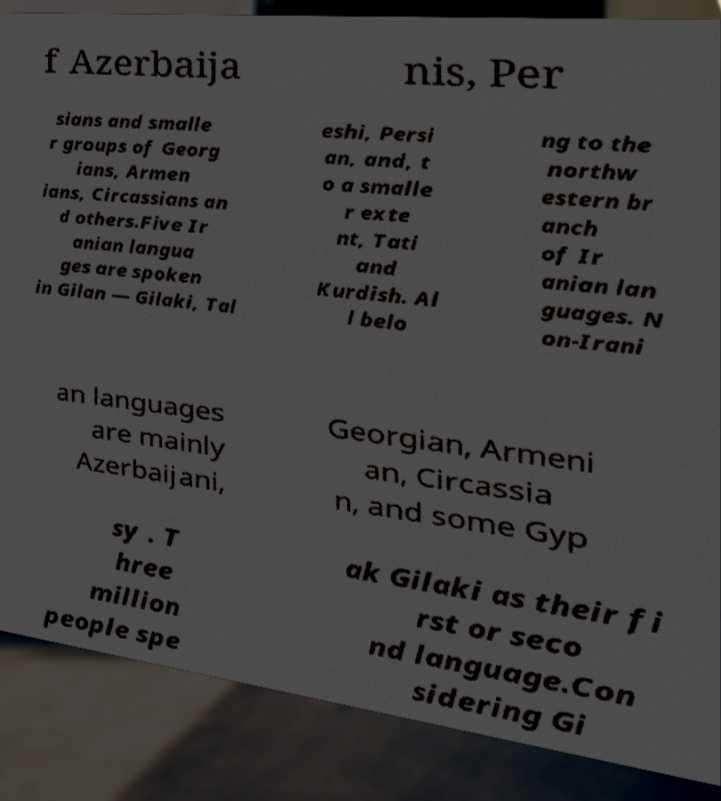Can you read and provide the text displayed in the image?This photo seems to have some interesting text. Can you extract and type it out for me? f Azerbaija nis, Per sians and smalle r groups of Georg ians, Armen ians, Circassians an d others.Five Ir anian langua ges are spoken in Gilan — Gilaki, Tal eshi, Persi an, and, t o a smalle r exte nt, Tati and Kurdish. Al l belo ng to the northw estern br anch of Ir anian lan guages. N on-Irani an languages are mainly Azerbaijani, Georgian, Armeni an, Circassia n, and some Gyp sy . T hree million people spe ak Gilaki as their fi rst or seco nd language.Con sidering Gi 